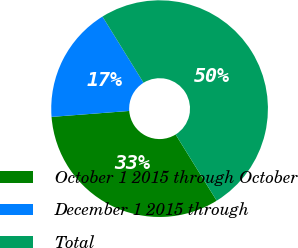<chart> <loc_0><loc_0><loc_500><loc_500><pie_chart><fcel>October 1 2015 through October<fcel>December 1 2015 through<fcel>Total<nl><fcel>32.62%<fcel>17.38%<fcel>50.0%<nl></chart> 